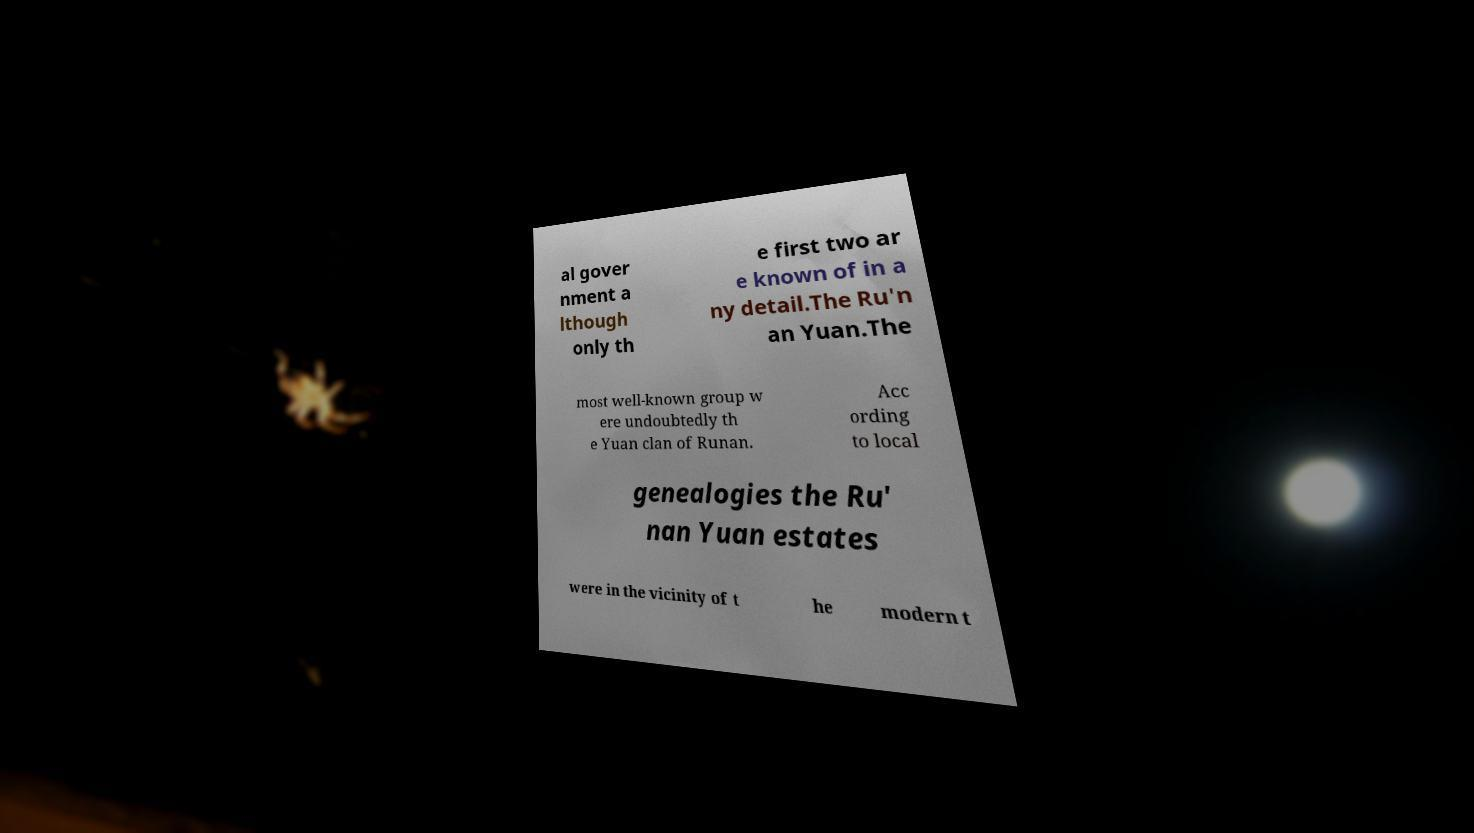Please identify and transcribe the text found in this image. al gover nment a lthough only th e first two ar e known of in a ny detail.The Ru'n an Yuan.The most well-known group w ere undoubtedly th e Yuan clan of Runan. Acc ording to local genealogies the Ru' nan Yuan estates were in the vicinity of t he modern t 